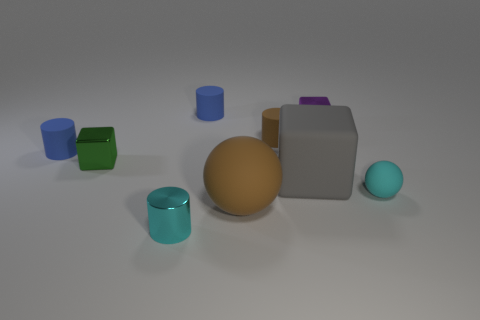Subtract all red blocks. Subtract all purple cylinders. How many blocks are left? 3 Add 1 small brown rubber cylinders. How many objects exist? 10 Subtract all cylinders. How many objects are left? 5 Add 1 small blue cylinders. How many small blue cylinders are left? 3 Add 3 matte cylinders. How many matte cylinders exist? 6 Subtract 0 yellow blocks. How many objects are left? 9 Subtract all green metal cylinders. Subtract all gray matte blocks. How many objects are left? 8 